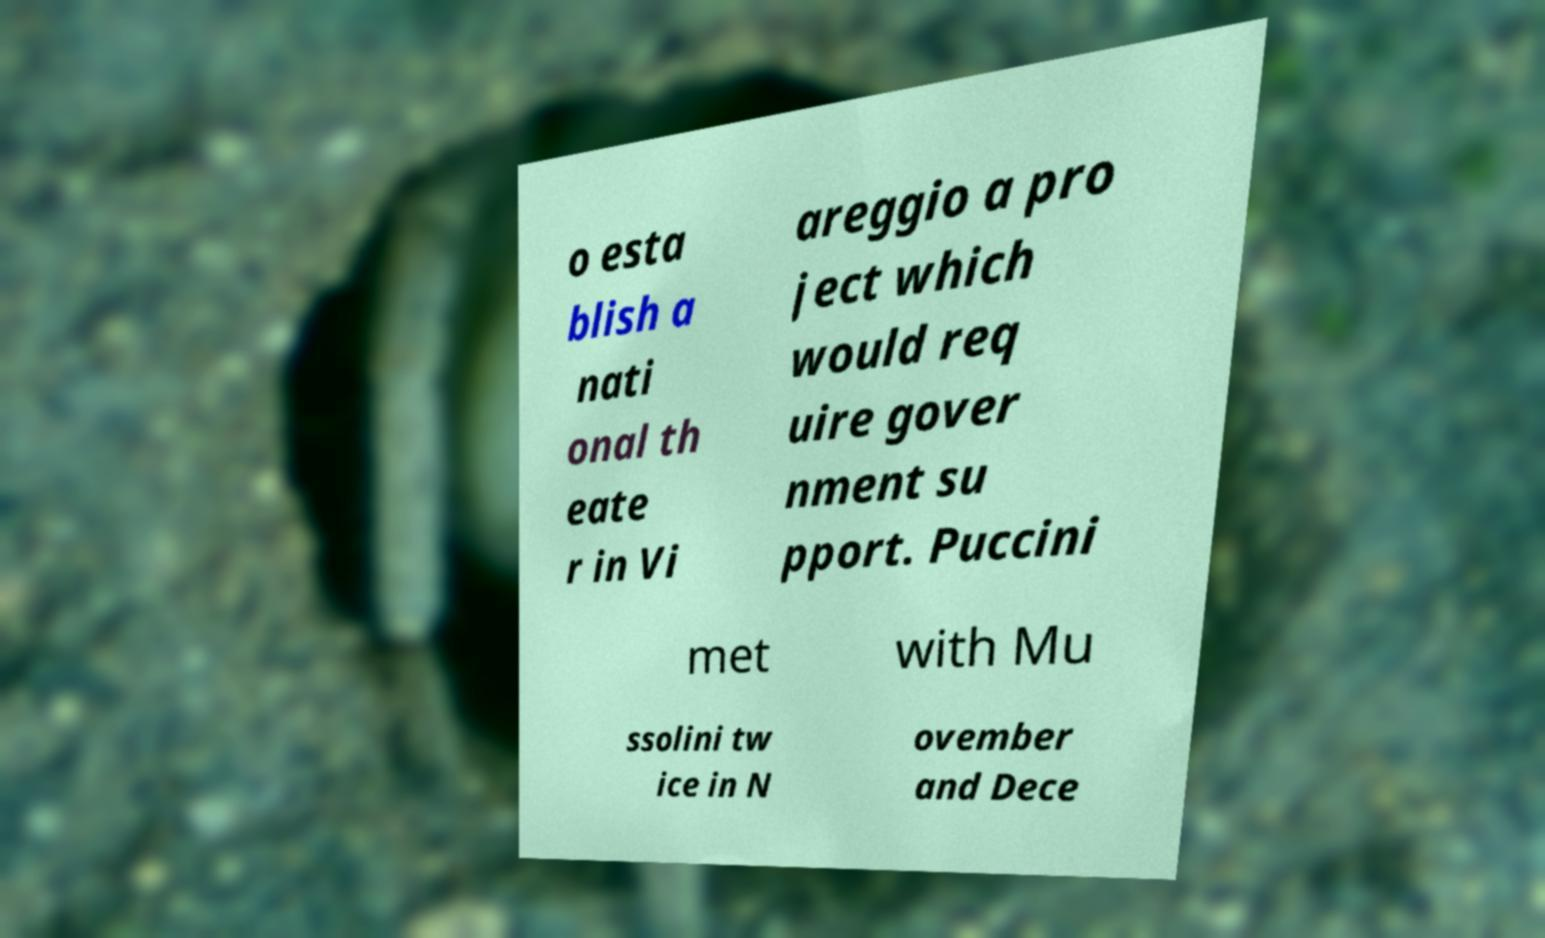What messages or text are displayed in this image? I need them in a readable, typed format. o esta blish a nati onal th eate r in Vi areggio a pro ject which would req uire gover nment su pport. Puccini met with Mu ssolini tw ice in N ovember and Dece 